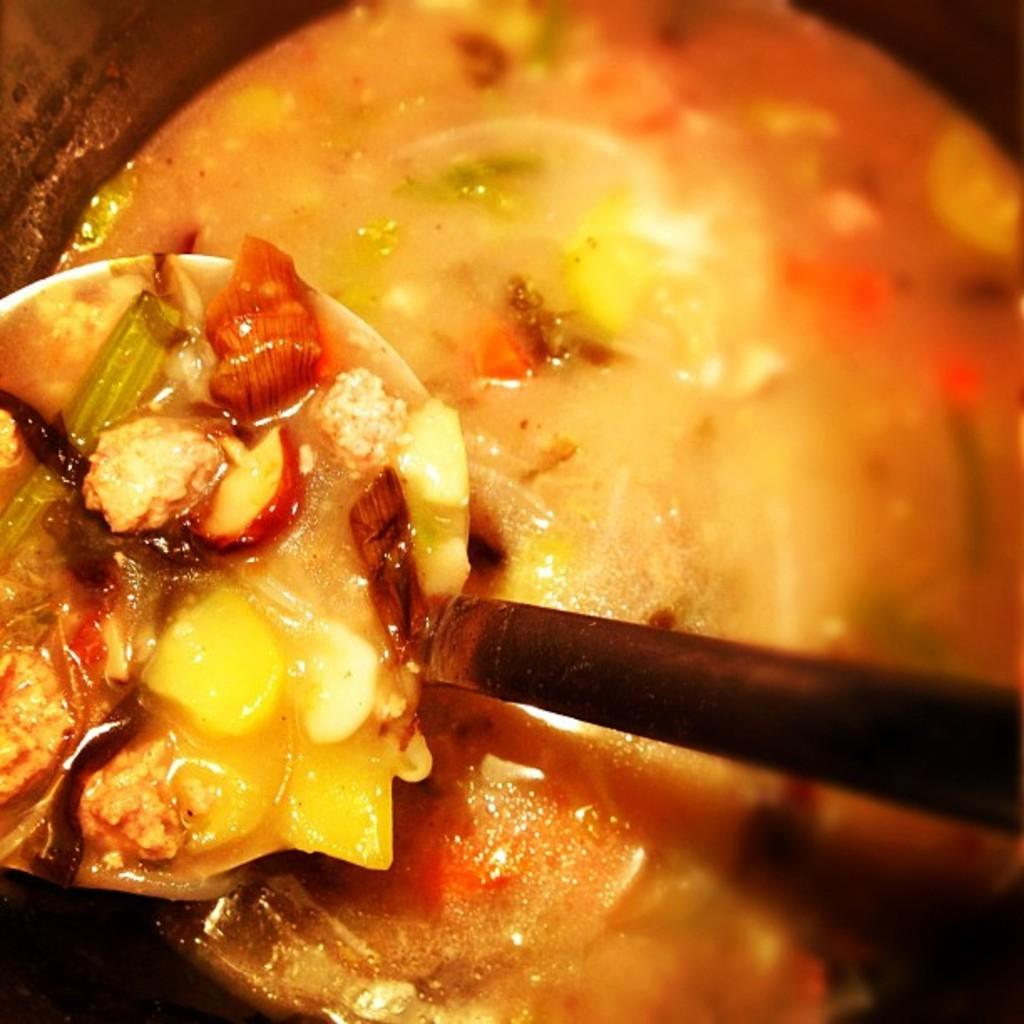What type of food is shown in the image? The image provides a close view of food, specifically a curry in a vessel. What utensil is visible in the image? There is a black-colored spoon in the image. How does the stem of the curry plant appear in the image? There is no curry plant or stem visible in the image; it only shows a curry in a vessel. Can you describe the wave-like pattern on the spoon in the image? There is no wave-like pattern on the spoon in the image; it is simply a black-colored spoon. 